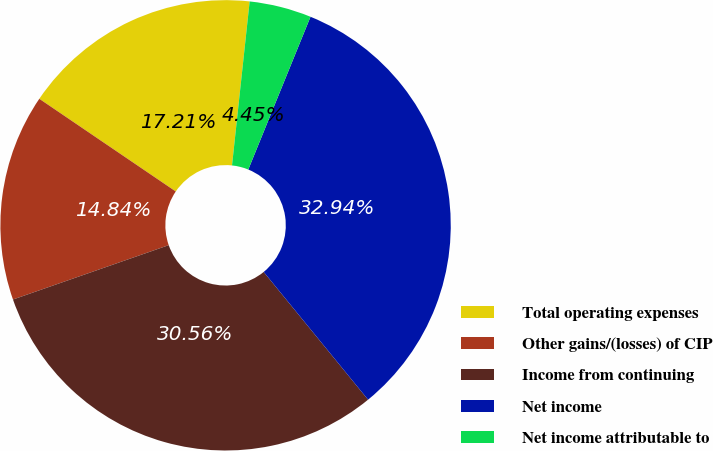<chart> <loc_0><loc_0><loc_500><loc_500><pie_chart><fcel>Total operating expenses<fcel>Other gains/(losses) of CIP<fcel>Income from continuing<fcel>Net income<fcel>Net income attributable to<nl><fcel>17.21%<fcel>14.84%<fcel>30.56%<fcel>32.94%<fcel>4.45%<nl></chart> 